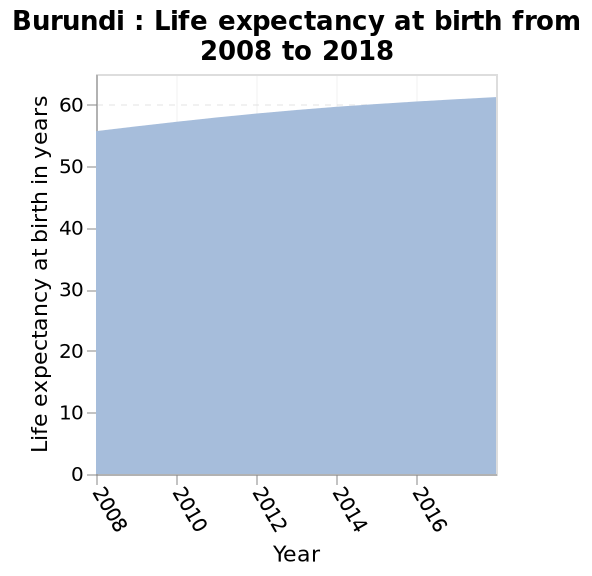<image>
In what span of time did the life expectancy at birth rise from 55 to 60 years?  The life expectancy at birth rose from 55 to 60 years in a span of 10 years, from 2008 to 2018. Did the life expectancy at birth decline from 55 to 60 years in a span of 10 years, from 2008 to 2018? No. The life expectancy at birth rose from 55 to 60 years in a span of 10 years, from 2008 to 2018. 